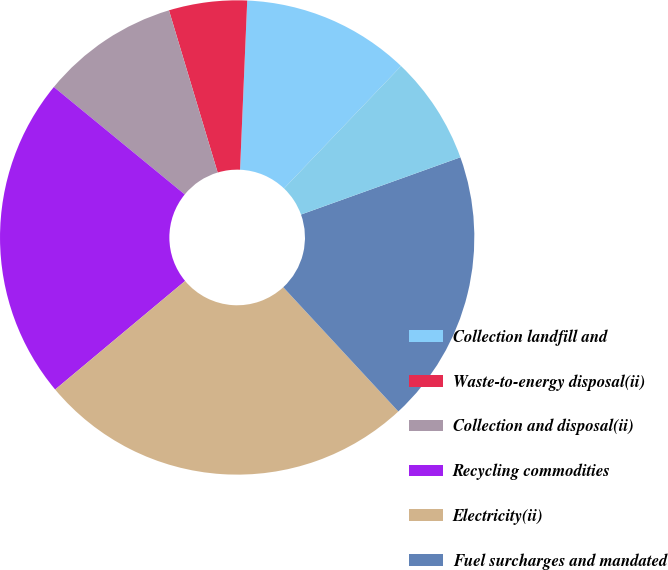Convert chart to OTSL. <chart><loc_0><loc_0><loc_500><loc_500><pie_chart><fcel>Collection landfill and<fcel>Waste-to-energy disposal(ii)<fcel>Collection and disposal(ii)<fcel>Recycling commodities<fcel>Electricity(ii)<fcel>Fuel surcharges and mandated<fcel>Total<nl><fcel>11.47%<fcel>5.32%<fcel>9.42%<fcel>22.02%<fcel>25.82%<fcel>18.6%<fcel>7.37%<nl></chart> 